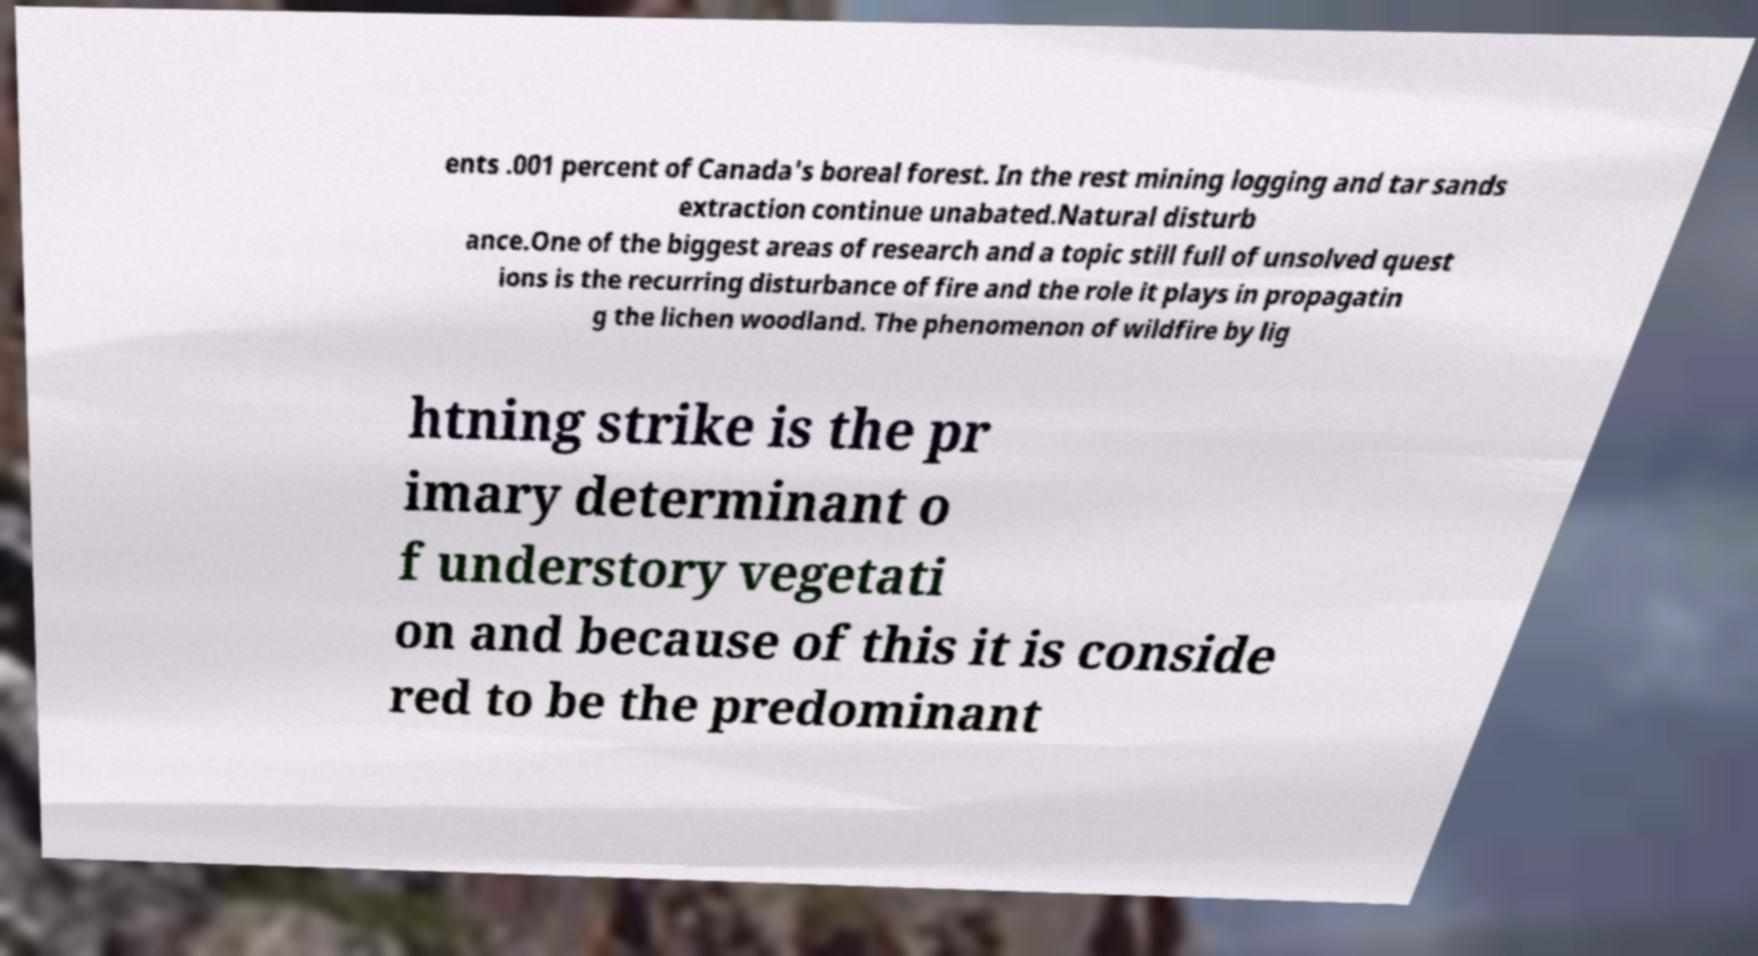What messages or text are displayed in this image? I need them in a readable, typed format. ents .001 percent of Canada's boreal forest. In the rest mining logging and tar sands extraction continue unabated.Natural disturb ance.One of the biggest areas of research and a topic still full of unsolved quest ions is the recurring disturbance of fire and the role it plays in propagatin g the lichen woodland. The phenomenon of wildfire by lig htning strike is the pr imary determinant o f understory vegetati on and because of this it is conside red to be the predominant 